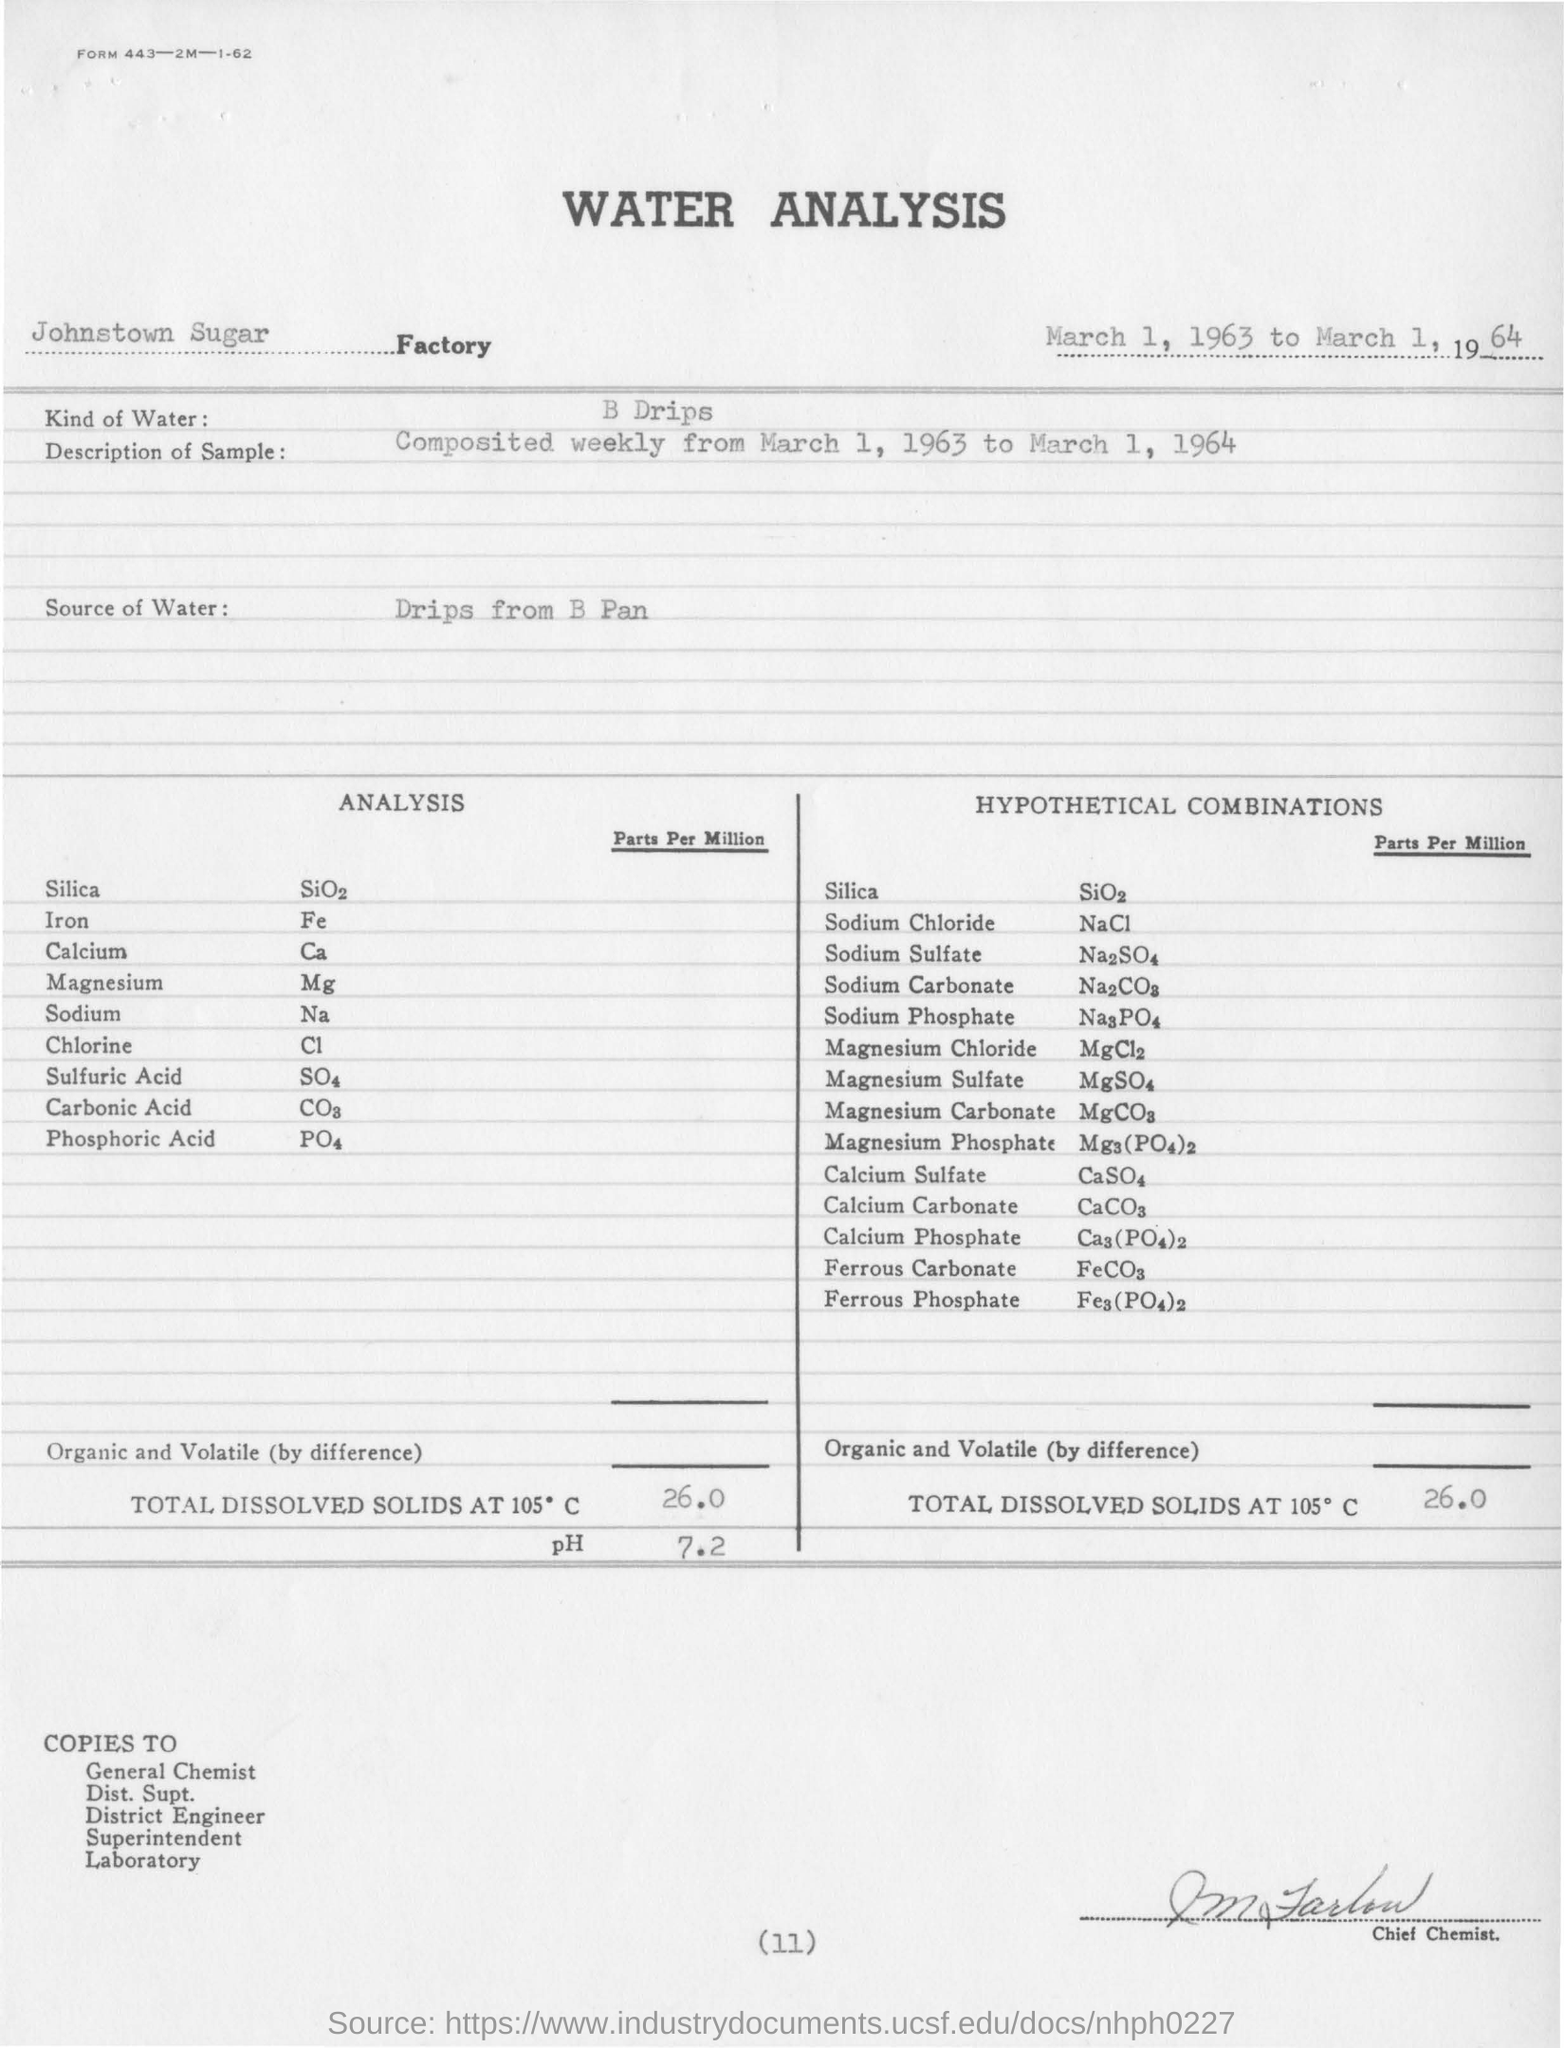What kind of water is used for water analysis ?
Give a very brief answer. B drips. What is the "description of sample "?
Give a very brief answer. Composited weekly from March 1, 1963 to March 1, 1964. What is the total dissolved solids present at 105 degree c parts per million for water analysis?
Offer a very short reply. 26.0. What is the total dissolved solids present at 105 degree c parts per million for hypothetical combination?
Keep it short and to the point. 26.0. What is the value of ph for conducted b drips kind of water?
Make the answer very short. 7.2. 